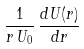Convert formula to latex. <formula><loc_0><loc_0><loc_500><loc_500>\frac { 1 } { r \, U _ { 0 } } \, \frac { d U ( r ) } { d r }</formula> 